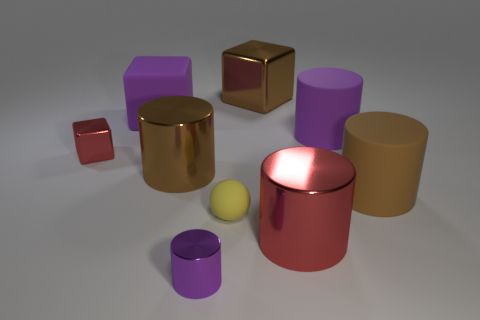Subtract all tiny purple cylinders. How many cylinders are left? 4 Add 1 small shiny blocks. How many objects exist? 10 Subtract all purple cylinders. How many cylinders are left? 3 Subtract 3 cylinders. How many cylinders are left? 2 Subtract all cylinders. Subtract all big purple cubes. How many objects are left? 3 Add 5 small red shiny blocks. How many small red shiny blocks are left? 6 Add 9 small yellow things. How many small yellow things exist? 10 Subtract 0 brown spheres. How many objects are left? 9 Subtract all cylinders. How many objects are left? 4 Subtract all green cylinders. Subtract all yellow cubes. How many cylinders are left? 5 